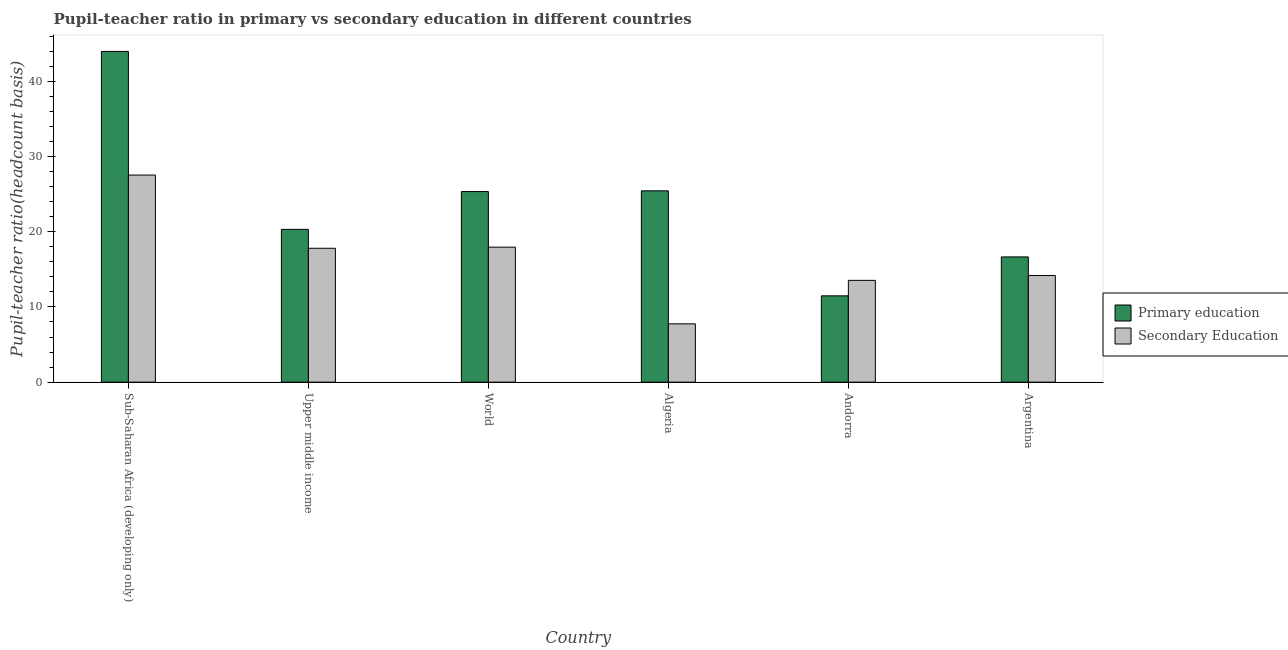Are the number of bars on each tick of the X-axis equal?
Give a very brief answer. Yes. How many bars are there on the 6th tick from the left?
Offer a very short reply. 2. How many bars are there on the 5th tick from the right?
Make the answer very short. 2. What is the label of the 4th group of bars from the left?
Your response must be concise. Algeria. What is the pupil teacher ratio on secondary education in Upper middle income?
Offer a terse response. 17.8. Across all countries, what is the maximum pupil teacher ratio on secondary education?
Your answer should be compact. 27.53. Across all countries, what is the minimum pupil teacher ratio on secondary education?
Ensure brevity in your answer.  7.75. In which country was the pupil-teacher ratio in primary education maximum?
Your answer should be compact. Sub-Saharan Africa (developing only). In which country was the pupil teacher ratio on secondary education minimum?
Your answer should be compact. Algeria. What is the total pupil-teacher ratio in primary education in the graph?
Your response must be concise. 143.18. What is the difference between the pupil-teacher ratio in primary education in Algeria and that in Upper middle income?
Your response must be concise. 5.13. What is the difference between the pupil teacher ratio on secondary education in Argentina and the pupil-teacher ratio in primary education in World?
Provide a succinct answer. -11.16. What is the average pupil teacher ratio on secondary education per country?
Keep it short and to the point. 16.46. What is the difference between the pupil teacher ratio on secondary education and pupil-teacher ratio in primary education in Algeria?
Provide a short and direct response. -17.68. In how many countries, is the pupil-teacher ratio in primary education greater than 12 ?
Ensure brevity in your answer.  5. What is the ratio of the pupil teacher ratio on secondary education in Sub-Saharan Africa (developing only) to that in Upper middle income?
Your response must be concise. 1.55. Is the difference between the pupil teacher ratio on secondary education in Upper middle income and World greater than the difference between the pupil-teacher ratio in primary education in Upper middle income and World?
Make the answer very short. Yes. What is the difference between the highest and the second highest pupil-teacher ratio in primary education?
Give a very brief answer. 18.53. What is the difference between the highest and the lowest pupil-teacher ratio in primary education?
Your response must be concise. 32.5. Is the sum of the pupil teacher ratio on secondary education in Algeria and World greater than the maximum pupil-teacher ratio in primary education across all countries?
Ensure brevity in your answer.  No. What does the 2nd bar from the left in World represents?
Keep it short and to the point. Secondary Education. What does the 1st bar from the right in Argentina represents?
Provide a short and direct response. Secondary Education. Are all the bars in the graph horizontal?
Make the answer very short. No. How many countries are there in the graph?
Give a very brief answer. 6. Does the graph contain any zero values?
Make the answer very short. No. Where does the legend appear in the graph?
Make the answer very short. Center right. How many legend labels are there?
Your response must be concise. 2. What is the title of the graph?
Offer a terse response. Pupil-teacher ratio in primary vs secondary education in different countries. What is the label or title of the Y-axis?
Provide a succinct answer. Pupil-teacher ratio(headcount basis). What is the Pupil-teacher ratio(headcount basis) of Primary education in Sub-Saharan Africa (developing only)?
Your response must be concise. 43.97. What is the Pupil-teacher ratio(headcount basis) in Secondary Education in Sub-Saharan Africa (developing only)?
Offer a very short reply. 27.53. What is the Pupil-teacher ratio(headcount basis) of Primary education in Upper middle income?
Provide a short and direct response. 20.31. What is the Pupil-teacher ratio(headcount basis) in Secondary Education in Upper middle income?
Your answer should be compact. 17.8. What is the Pupil-teacher ratio(headcount basis) of Primary education in World?
Your answer should be compact. 25.34. What is the Pupil-teacher ratio(headcount basis) in Secondary Education in World?
Your answer should be compact. 17.95. What is the Pupil-teacher ratio(headcount basis) of Primary education in Algeria?
Give a very brief answer. 25.44. What is the Pupil-teacher ratio(headcount basis) in Secondary Education in Algeria?
Ensure brevity in your answer.  7.75. What is the Pupil-teacher ratio(headcount basis) of Primary education in Andorra?
Ensure brevity in your answer.  11.47. What is the Pupil-teacher ratio(headcount basis) in Secondary Education in Andorra?
Offer a terse response. 13.53. What is the Pupil-teacher ratio(headcount basis) in Primary education in Argentina?
Your answer should be very brief. 16.65. What is the Pupil-teacher ratio(headcount basis) of Secondary Education in Argentina?
Keep it short and to the point. 14.18. Across all countries, what is the maximum Pupil-teacher ratio(headcount basis) in Primary education?
Offer a very short reply. 43.97. Across all countries, what is the maximum Pupil-teacher ratio(headcount basis) of Secondary Education?
Give a very brief answer. 27.53. Across all countries, what is the minimum Pupil-teacher ratio(headcount basis) in Primary education?
Provide a succinct answer. 11.47. Across all countries, what is the minimum Pupil-teacher ratio(headcount basis) in Secondary Education?
Your answer should be compact. 7.75. What is the total Pupil-teacher ratio(headcount basis) of Primary education in the graph?
Your response must be concise. 143.18. What is the total Pupil-teacher ratio(headcount basis) of Secondary Education in the graph?
Keep it short and to the point. 98.74. What is the difference between the Pupil-teacher ratio(headcount basis) of Primary education in Sub-Saharan Africa (developing only) and that in Upper middle income?
Offer a terse response. 23.66. What is the difference between the Pupil-teacher ratio(headcount basis) of Secondary Education in Sub-Saharan Africa (developing only) and that in Upper middle income?
Make the answer very short. 9.73. What is the difference between the Pupil-teacher ratio(headcount basis) in Primary education in Sub-Saharan Africa (developing only) and that in World?
Your answer should be very brief. 18.63. What is the difference between the Pupil-teacher ratio(headcount basis) in Secondary Education in Sub-Saharan Africa (developing only) and that in World?
Make the answer very short. 9.58. What is the difference between the Pupil-teacher ratio(headcount basis) of Primary education in Sub-Saharan Africa (developing only) and that in Algeria?
Your response must be concise. 18.53. What is the difference between the Pupil-teacher ratio(headcount basis) of Secondary Education in Sub-Saharan Africa (developing only) and that in Algeria?
Offer a very short reply. 19.78. What is the difference between the Pupil-teacher ratio(headcount basis) in Primary education in Sub-Saharan Africa (developing only) and that in Andorra?
Your answer should be compact. 32.5. What is the difference between the Pupil-teacher ratio(headcount basis) of Secondary Education in Sub-Saharan Africa (developing only) and that in Andorra?
Provide a succinct answer. 14. What is the difference between the Pupil-teacher ratio(headcount basis) in Primary education in Sub-Saharan Africa (developing only) and that in Argentina?
Offer a very short reply. 27.32. What is the difference between the Pupil-teacher ratio(headcount basis) of Secondary Education in Sub-Saharan Africa (developing only) and that in Argentina?
Your response must be concise. 13.35. What is the difference between the Pupil-teacher ratio(headcount basis) in Primary education in Upper middle income and that in World?
Your answer should be very brief. -5.03. What is the difference between the Pupil-teacher ratio(headcount basis) of Secondary Education in Upper middle income and that in World?
Make the answer very short. -0.15. What is the difference between the Pupil-teacher ratio(headcount basis) of Primary education in Upper middle income and that in Algeria?
Provide a succinct answer. -5.13. What is the difference between the Pupil-teacher ratio(headcount basis) of Secondary Education in Upper middle income and that in Algeria?
Offer a very short reply. 10.05. What is the difference between the Pupil-teacher ratio(headcount basis) of Primary education in Upper middle income and that in Andorra?
Offer a very short reply. 8.84. What is the difference between the Pupil-teacher ratio(headcount basis) in Secondary Education in Upper middle income and that in Andorra?
Offer a terse response. 4.27. What is the difference between the Pupil-teacher ratio(headcount basis) of Primary education in Upper middle income and that in Argentina?
Give a very brief answer. 3.66. What is the difference between the Pupil-teacher ratio(headcount basis) of Secondary Education in Upper middle income and that in Argentina?
Give a very brief answer. 3.62. What is the difference between the Pupil-teacher ratio(headcount basis) in Primary education in World and that in Algeria?
Offer a very short reply. -0.1. What is the difference between the Pupil-teacher ratio(headcount basis) in Secondary Education in World and that in Algeria?
Offer a terse response. 10.2. What is the difference between the Pupil-teacher ratio(headcount basis) in Primary education in World and that in Andorra?
Make the answer very short. 13.86. What is the difference between the Pupil-teacher ratio(headcount basis) in Secondary Education in World and that in Andorra?
Your response must be concise. 4.42. What is the difference between the Pupil-teacher ratio(headcount basis) in Primary education in World and that in Argentina?
Provide a succinct answer. 8.69. What is the difference between the Pupil-teacher ratio(headcount basis) in Secondary Education in World and that in Argentina?
Keep it short and to the point. 3.77. What is the difference between the Pupil-teacher ratio(headcount basis) in Primary education in Algeria and that in Andorra?
Your answer should be very brief. 13.96. What is the difference between the Pupil-teacher ratio(headcount basis) in Secondary Education in Algeria and that in Andorra?
Provide a short and direct response. -5.78. What is the difference between the Pupil-teacher ratio(headcount basis) in Primary education in Algeria and that in Argentina?
Give a very brief answer. 8.79. What is the difference between the Pupil-teacher ratio(headcount basis) in Secondary Education in Algeria and that in Argentina?
Make the answer very short. -6.42. What is the difference between the Pupil-teacher ratio(headcount basis) in Primary education in Andorra and that in Argentina?
Ensure brevity in your answer.  -5.18. What is the difference between the Pupil-teacher ratio(headcount basis) of Secondary Education in Andorra and that in Argentina?
Make the answer very short. -0.64. What is the difference between the Pupil-teacher ratio(headcount basis) of Primary education in Sub-Saharan Africa (developing only) and the Pupil-teacher ratio(headcount basis) of Secondary Education in Upper middle income?
Offer a very short reply. 26.17. What is the difference between the Pupil-teacher ratio(headcount basis) in Primary education in Sub-Saharan Africa (developing only) and the Pupil-teacher ratio(headcount basis) in Secondary Education in World?
Give a very brief answer. 26.02. What is the difference between the Pupil-teacher ratio(headcount basis) in Primary education in Sub-Saharan Africa (developing only) and the Pupil-teacher ratio(headcount basis) in Secondary Education in Algeria?
Offer a very short reply. 36.22. What is the difference between the Pupil-teacher ratio(headcount basis) in Primary education in Sub-Saharan Africa (developing only) and the Pupil-teacher ratio(headcount basis) in Secondary Education in Andorra?
Make the answer very short. 30.44. What is the difference between the Pupil-teacher ratio(headcount basis) of Primary education in Sub-Saharan Africa (developing only) and the Pupil-teacher ratio(headcount basis) of Secondary Education in Argentina?
Your answer should be very brief. 29.8. What is the difference between the Pupil-teacher ratio(headcount basis) in Primary education in Upper middle income and the Pupil-teacher ratio(headcount basis) in Secondary Education in World?
Offer a very short reply. 2.36. What is the difference between the Pupil-teacher ratio(headcount basis) of Primary education in Upper middle income and the Pupil-teacher ratio(headcount basis) of Secondary Education in Algeria?
Provide a succinct answer. 12.56. What is the difference between the Pupil-teacher ratio(headcount basis) in Primary education in Upper middle income and the Pupil-teacher ratio(headcount basis) in Secondary Education in Andorra?
Your answer should be compact. 6.78. What is the difference between the Pupil-teacher ratio(headcount basis) of Primary education in Upper middle income and the Pupil-teacher ratio(headcount basis) of Secondary Education in Argentina?
Your answer should be compact. 6.14. What is the difference between the Pupil-teacher ratio(headcount basis) in Primary education in World and the Pupil-teacher ratio(headcount basis) in Secondary Education in Algeria?
Give a very brief answer. 17.59. What is the difference between the Pupil-teacher ratio(headcount basis) of Primary education in World and the Pupil-teacher ratio(headcount basis) of Secondary Education in Andorra?
Your response must be concise. 11.81. What is the difference between the Pupil-teacher ratio(headcount basis) of Primary education in World and the Pupil-teacher ratio(headcount basis) of Secondary Education in Argentina?
Your answer should be very brief. 11.16. What is the difference between the Pupil-teacher ratio(headcount basis) of Primary education in Algeria and the Pupil-teacher ratio(headcount basis) of Secondary Education in Andorra?
Your response must be concise. 11.9. What is the difference between the Pupil-teacher ratio(headcount basis) of Primary education in Algeria and the Pupil-teacher ratio(headcount basis) of Secondary Education in Argentina?
Your response must be concise. 11.26. What is the difference between the Pupil-teacher ratio(headcount basis) in Primary education in Andorra and the Pupil-teacher ratio(headcount basis) in Secondary Education in Argentina?
Make the answer very short. -2.7. What is the average Pupil-teacher ratio(headcount basis) of Primary education per country?
Your response must be concise. 23.86. What is the average Pupil-teacher ratio(headcount basis) of Secondary Education per country?
Your response must be concise. 16.46. What is the difference between the Pupil-teacher ratio(headcount basis) in Primary education and Pupil-teacher ratio(headcount basis) in Secondary Education in Sub-Saharan Africa (developing only)?
Your answer should be very brief. 16.44. What is the difference between the Pupil-teacher ratio(headcount basis) of Primary education and Pupil-teacher ratio(headcount basis) of Secondary Education in Upper middle income?
Ensure brevity in your answer.  2.51. What is the difference between the Pupil-teacher ratio(headcount basis) of Primary education and Pupil-teacher ratio(headcount basis) of Secondary Education in World?
Ensure brevity in your answer.  7.39. What is the difference between the Pupil-teacher ratio(headcount basis) of Primary education and Pupil-teacher ratio(headcount basis) of Secondary Education in Algeria?
Provide a short and direct response. 17.68. What is the difference between the Pupil-teacher ratio(headcount basis) in Primary education and Pupil-teacher ratio(headcount basis) in Secondary Education in Andorra?
Provide a succinct answer. -2.06. What is the difference between the Pupil-teacher ratio(headcount basis) in Primary education and Pupil-teacher ratio(headcount basis) in Secondary Education in Argentina?
Give a very brief answer. 2.48. What is the ratio of the Pupil-teacher ratio(headcount basis) of Primary education in Sub-Saharan Africa (developing only) to that in Upper middle income?
Keep it short and to the point. 2.16. What is the ratio of the Pupil-teacher ratio(headcount basis) of Secondary Education in Sub-Saharan Africa (developing only) to that in Upper middle income?
Provide a succinct answer. 1.55. What is the ratio of the Pupil-teacher ratio(headcount basis) in Primary education in Sub-Saharan Africa (developing only) to that in World?
Give a very brief answer. 1.74. What is the ratio of the Pupil-teacher ratio(headcount basis) in Secondary Education in Sub-Saharan Africa (developing only) to that in World?
Offer a terse response. 1.53. What is the ratio of the Pupil-teacher ratio(headcount basis) of Primary education in Sub-Saharan Africa (developing only) to that in Algeria?
Provide a short and direct response. 1.73. What is the ratio of the Pupil-teacher ratio(headcount basis) in Secondary Education in Sub-Saharan Africa (developing only) to that in Algeria?
Ensure brevity in your answer.  3.55. What is the ratio of the Pupil-teacher ratio(headcount basis) of Primary education in Sub-Saharan Africa (developing only) to that in Andorra?
Offer a very short reply. 3.83. What is the ratio of the Pupil-teacher ratio(headcount basis) of Secondary Education in Sub-Saharan Africa (developing only) to that in Andorra?
Give a very brief answer. 2.03. What is the ratio of the Pupil-teacher ratio(headcount basis) in Primary education in Sub-Saharan Africa (developing only) to that in Argentina?
Give a very brief answer. 2.64. What is the ratio of the Pupil-teacher ratio(headcount basis) of Secondary Education in Sub-Saharan Africa (developing only) to that in Argentina?
Make the answer very short. 1.94. What is the ratio of the Pupil-teacher ratio(headcount basis) in Primary education in Upper middle income to that in World?
Offer a very short reply. 0.8. What is the ratio of the Pupil-teacher ratio(headcount basis) of Primary education in Upper middle income to that in Algeria?
Keep it short and to the point. 0.8. What is the ratio of the Pupil-teacher ratio(headcount basis) in Secondary Education in Upper middle income to that in Algeria?
Offer a terse response. 2.3. What is the ratio of the Pupil-teacher ratio(headcount basis) in Primary education in Upper middle income to that in Andorra?
Ensure brevity in your answer.  1.77. What is the ratio of the Pupil-teacher ratio(headcount basis) in Secondary Education in Upper middle income to that in Andorra?
Your response must be concise. 1.32. What is the ratio of the Pupil-teacher ratio(headcount basis) of Primary education in Upper middle income to that in Argentina?
Give a very brief answer. 1.22. What is the ratio of the Pupil-teacher ratio(headcount basis) of Secondary Education in Upper middle income to that in Argentina?
Offer a very short reply. 1.26. What is the ratio of the Pupil-teacher ratio(headcount basis) of Secondary Education in World to that in Algeria?
Provide a short and direct response. 2.32. What is the ratio of the Pupil-teacher ratio(headcount basis) in Primary education in World to that in Andorra?
Offer a terse response. 2.21. What is the ratio of the Pupil-teacher ratio(headcount basis) of Secondary Education in World to that in Andorra?
Ensure brevity in your answer.  1.33. What is the ratio of the Pupil-teacher ratio(headcount basis) of Primary education in World to that in Argentina?
Give a very brief answer. 1.52. What is the ratio of the Pupil-teacher ratio(headcount basis) of Secondary Education in World to that in Argentina?
Make the answer very short. 1.27. What is the ratio of the Pupil-teacher ratio(headcount basis) of Primary education in Algeria to that in Andorra?
Offer a terse response. 2.22. What is the ratio of the Pupil-teacher ratio(headcount basis) in Secondary Education in Algeria to that in Andorra?
Give a very brief answer. 0.57. What is the ratio of the Pupil-teacher ratio(headcount basis) in Primary education in Algeria to that in Argentina?
Your answer should be compact. 1.53. What is the ratio of the Pupil-teacher ratio(headcount basis) of Secondary Education in Algeria to that in Argentina?
Ensure brevity in your answer.  0.55. What is the ratio of the Pupil-teacher ratio(headcount basis) of Primary education in Andorra to that in Argentina?
Offer a very short reply. 0.69. What is the ratio of the Pupil-teacher ratio(headcount basis) in Secondary Education in Andorra to that in Argentina?
Ensure brevity in your answer.  0.95. What is the difference between the highest and the second highest Pupil-teacher ratio(headcount basis) of Primary education?
Make the answer very short. 18.53. What is the difference between the highest and the second highest Pupil-teacher ratio(headcount basis) in Secondary Education?
Your response must be concise. 9.58. What is the difference between the highest and the lowest Pupil-teacher ratio(headcount basis) in Primary education?
Make the answer very short. 32.5. What is the difference between the highest and the lowest Pupil-teacher ratio(headcount basis) in Secondary Education?
Offer a terse response. 19.78. 